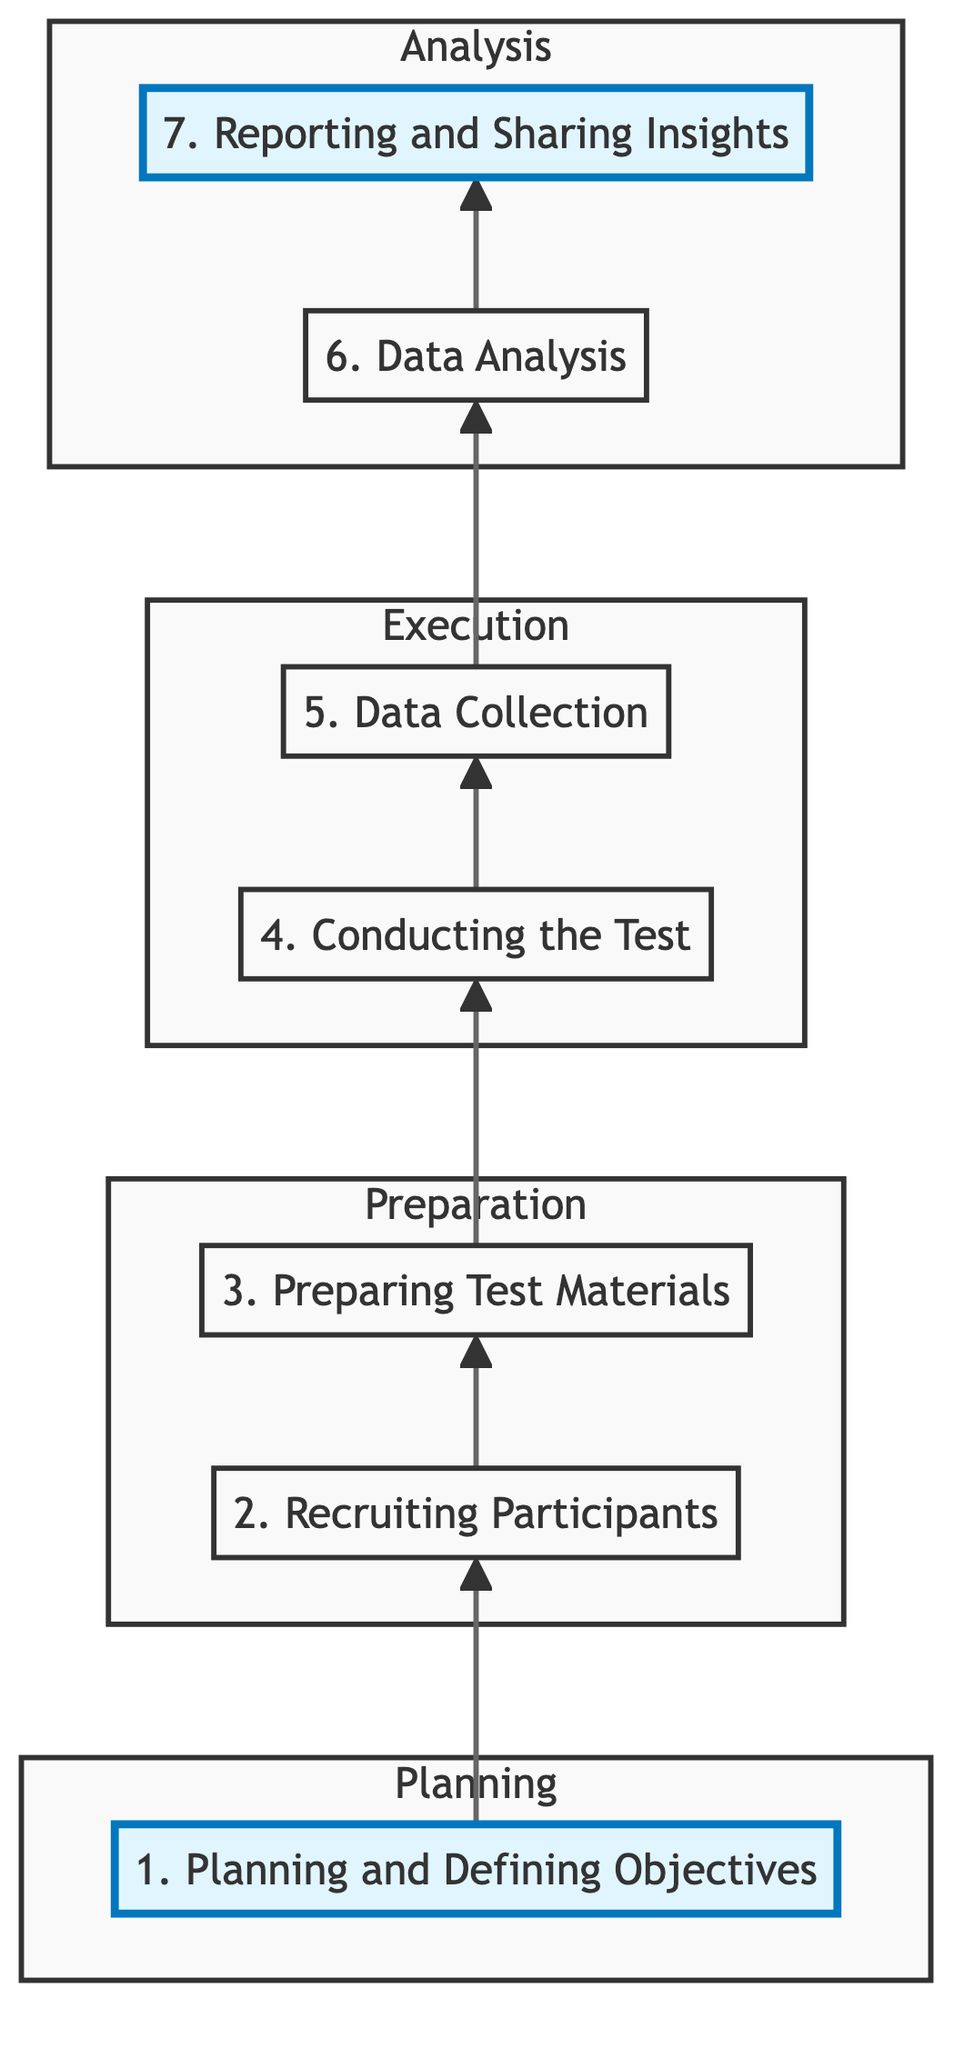What is the first step in the usability testing process? The first node at the bottom of the flow chart is labeled "1. Planning and Defining Objectives," indicating that this is the first step in the process.
Answer: Planning and Defining Objectives How many total steps are there in the usability testing process? Counting the nodes in the flow chart, there are seven steps from the bottom to the top, as indicated by the elements listed in the diagram.
Answer: Seven What is the last step in the process? The top node in the flow chart is labeled "7. Reporting and Sharing Insights," which shows this is the final step in the usability testing process.
Answer: Reporting and Sharing Insights Which step follows "Conducting the Test"? The flow chart indicates that after "4. Conducting the Test," the next step is "5. Data Collection," moving sequentially upward in the diagram.
Answer: Data Collection Which group of steps is categorized under analysis? The final two nodes, "6. Data Analysis" and "7. Reporting and Sharing Insights," are grouped under the analysis section, showing these are focused on evaluating the collected data and sharing the results.
Answer: Data Analysis and Reporting and Sharing Insights What key action is associated with "Preparing Test Materials"? The node labeled "3. Preparing Test Materials" lists key actions, and one of them is "Develop realistic task scenarios," indicating this is a specific activity for this step.
Answer: Develop realistic task scenarios What is the primary goal of the step labeled "Planning and Defining Objectives"? The description under "1. Planning and Defining Objectives" states that this step involves establishing the goals and metrics for the usability test, outlining the importance of defining clear objectives for the process.
Answer: Establishing goals and metrics Which step involves collecting feedback from participants? According to the flow chart, "5. Data Collection" specifically mentions the action of collecting feedback and usability data from participants, indicating this is where feedback is gathered.
Answer: Data Collection 